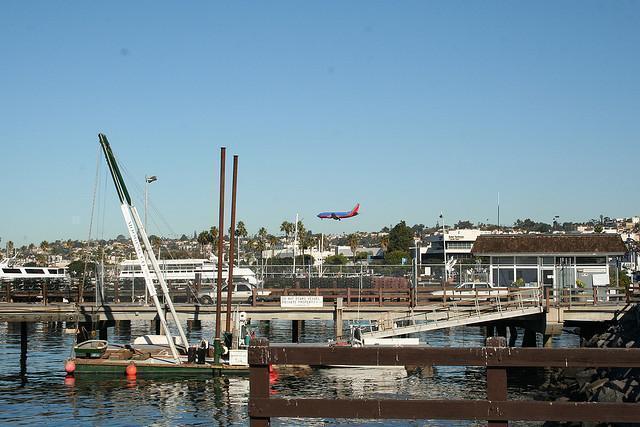What is soaring through the air?
Indicate the correct response by choosing from the four available options to answer the question.
Options: Bat, kite, zeppelin, airplane. Airplane. 